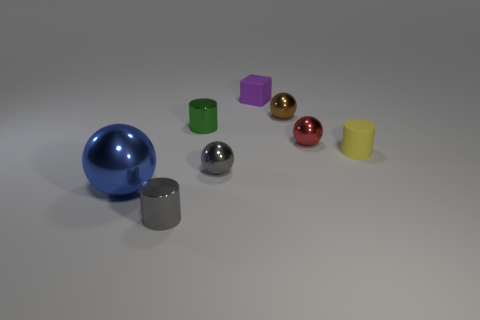Subtract all gray shiny cylinders. How many cylinders are left? 2 Subtract all red balls. How many balls are left? 3 Subtract 1 cubes. How many cubes are left? 0 Add 2 big red metallic spheres. How many objects exist? 10 Subtract all brown blocks. Subtract all blue cylinders. How many blocks are left? 1 Subtract all yellow cylinders. How many purple balls are left? 0 Subtract all big balls. Subtract all tiny spheres. How many objects are left? 4 Add 8 gray metal objects. How many gray metal objects are left? 10 Add 3 small shiny cylinders. How many small shiny cylinders exist? 5 Subtract 1 yellow cylinders. How many objects are left? 7 